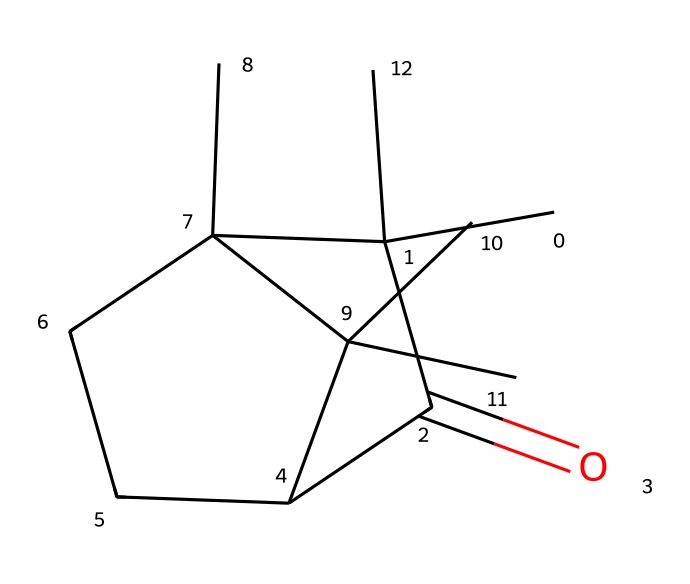What is the molecular formula of camphor? To determine the molecular formula, count the number of carbon (C), hydrogen (H), and oxygen (O) atoms in the SMILES representation. In this case, there are 10 carbons, 16 hydrogens, and 1 oxygen, which gives the molecular formula C10H16O.
Answer: C10H16O How many rings are present in camphor? The chemical structure reveals two distinct cycloalkane rings in the compound. A careful analysis of the structure shows that it is made up of two fused cyclopentane rings.
Answer: 2 What type of functional group is present in camphor? In the SMILES, the presence of the carbonyl (C=O) group, typically found in ketones, indicates that camphor possesses a ketone functional group.
Answer: ketone What is the saturation level of camphor? Analyzing the structure, camphor contains no double bonds apart from the carbonyl. This implies it is classified as a saturated compound despite the presence of rings.
Answer: saturated How many chiral centers are in camphor? By examining the molecular structure, it is evident that camphor contains two stereogenic (chiral) centers due to its structure allowing for mirror image forms.
Answer: 2 Is camphor a cyclic compound? The arrangement of carbon atoms in the SMILES structure reveals that camphor consists of cycloalkane segments, indicating it is indeed a cyclic compound.
Answer: yes 